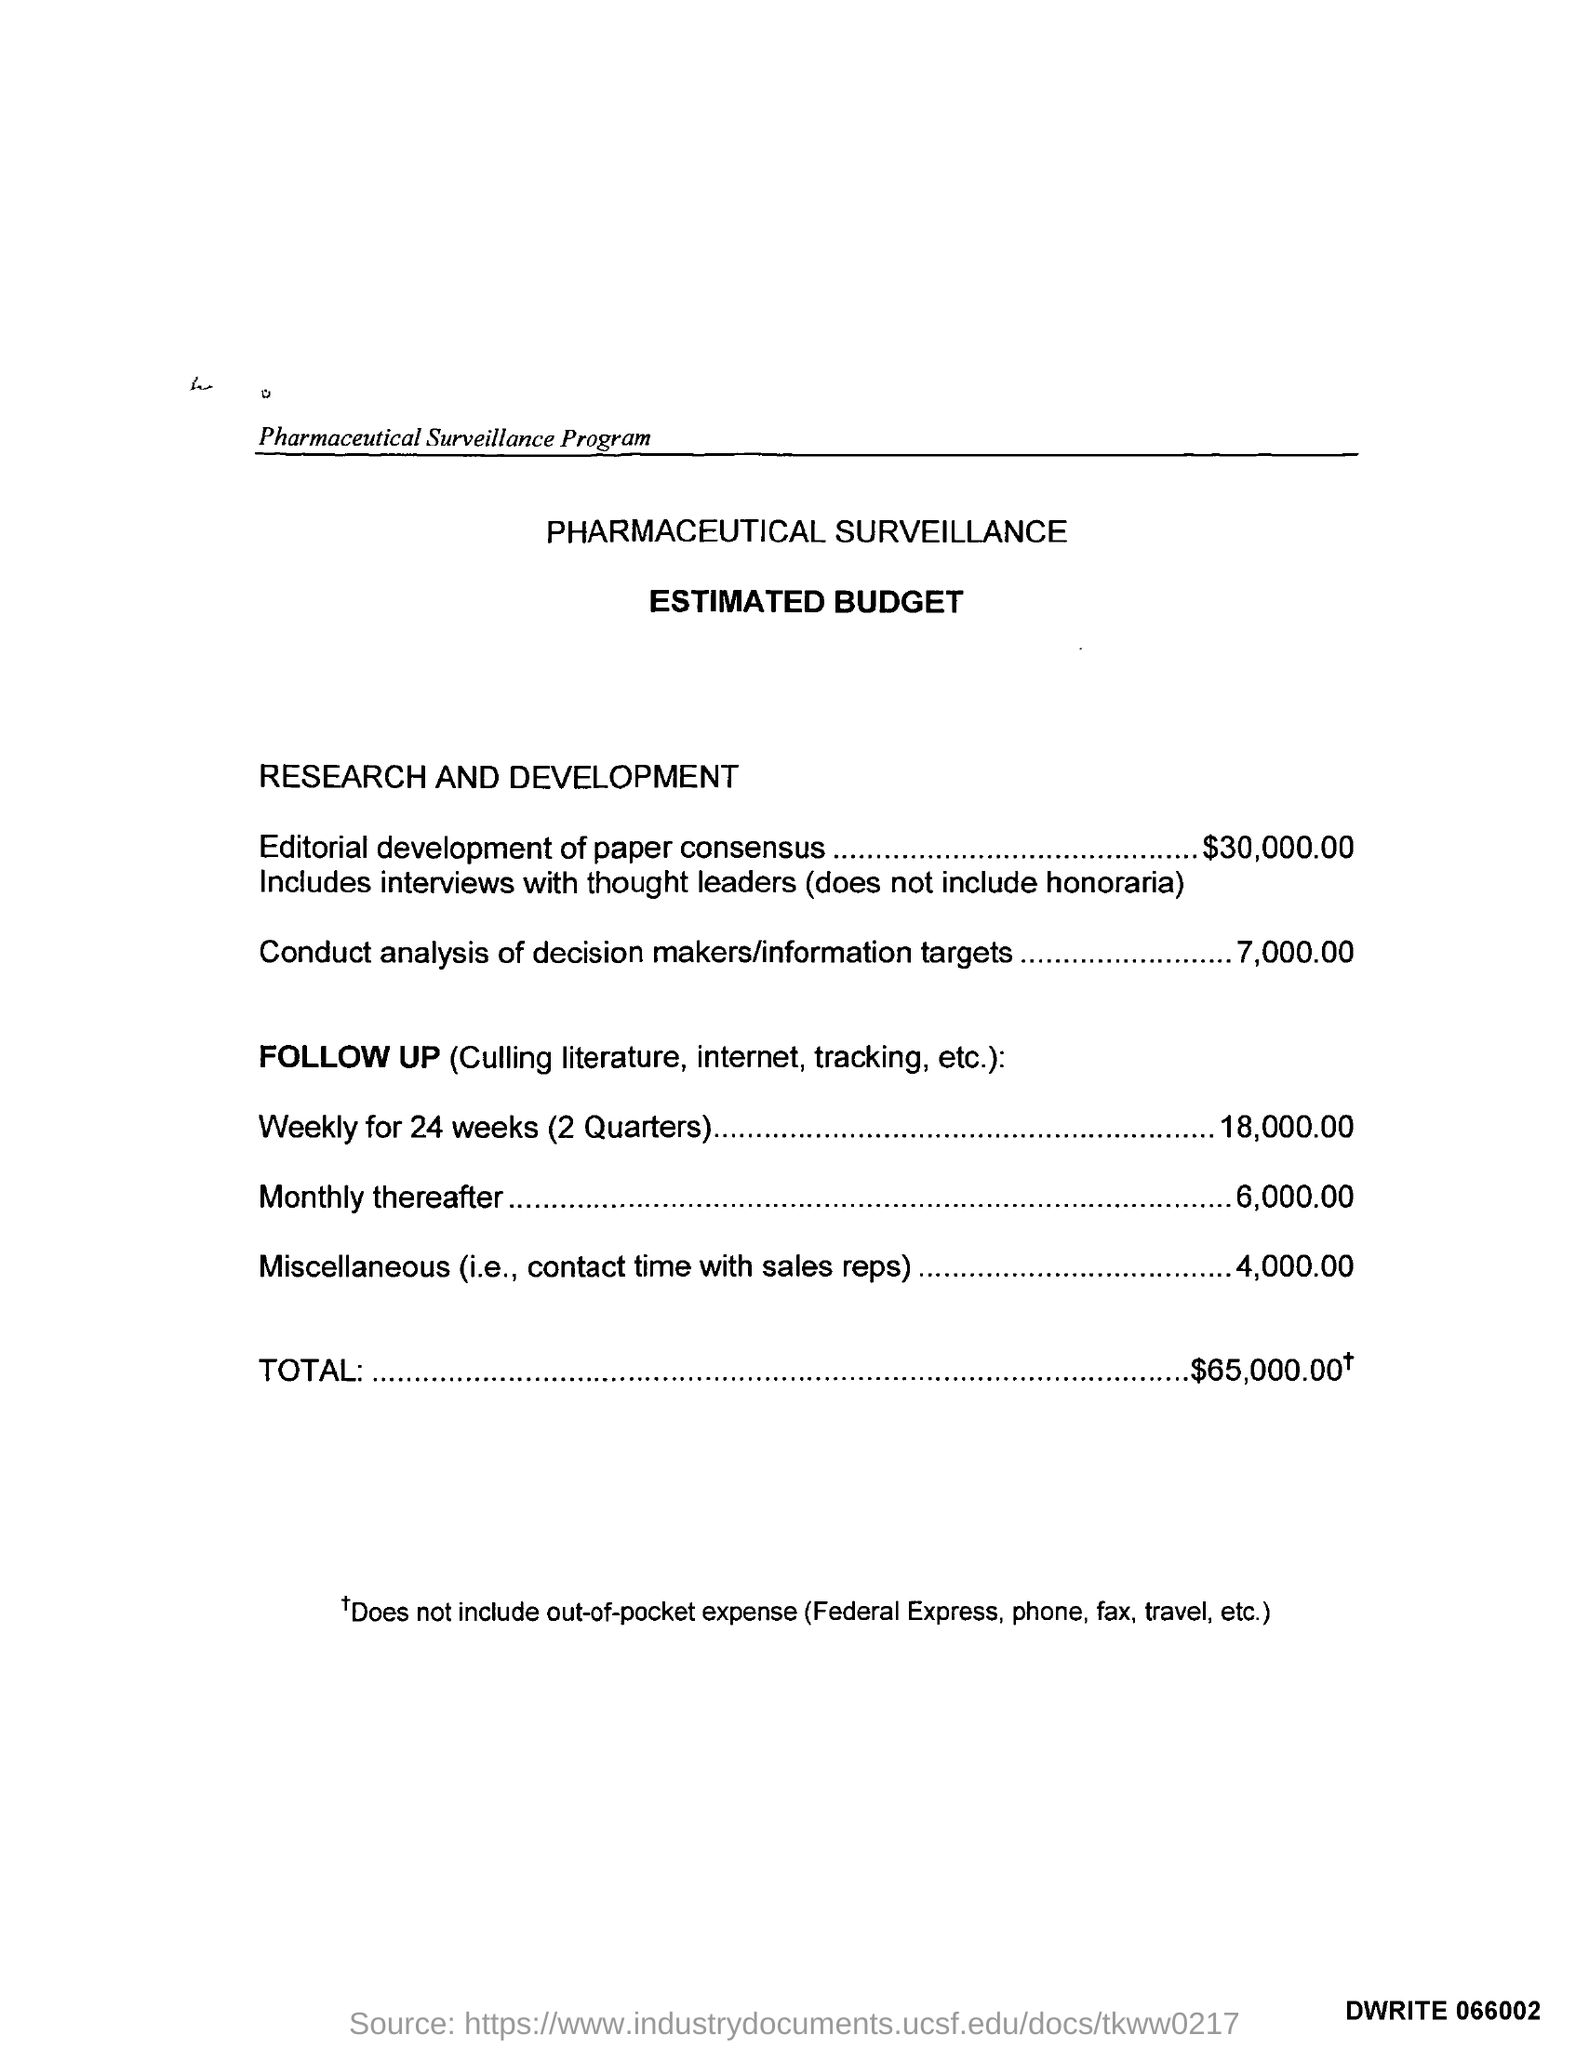What does the follow-up activity entail, and why is it split into weekly and monthly costs? The follow-up activity, priced at $18,000 for weekly tracking over 24 weeks and $6,000 for monthly tracking thereafter, likely involves continuous monitoring of published literature, internet resources, and other tracking mechanisms to stay informed on the relevant subjects in the program. The reason for splitting the costs could be due to an anticipated decrease in the intensity of follow-up needed after the initial 24 weeks, perhaps because the majority of data collection and analysis occurs in the first two quarters. 